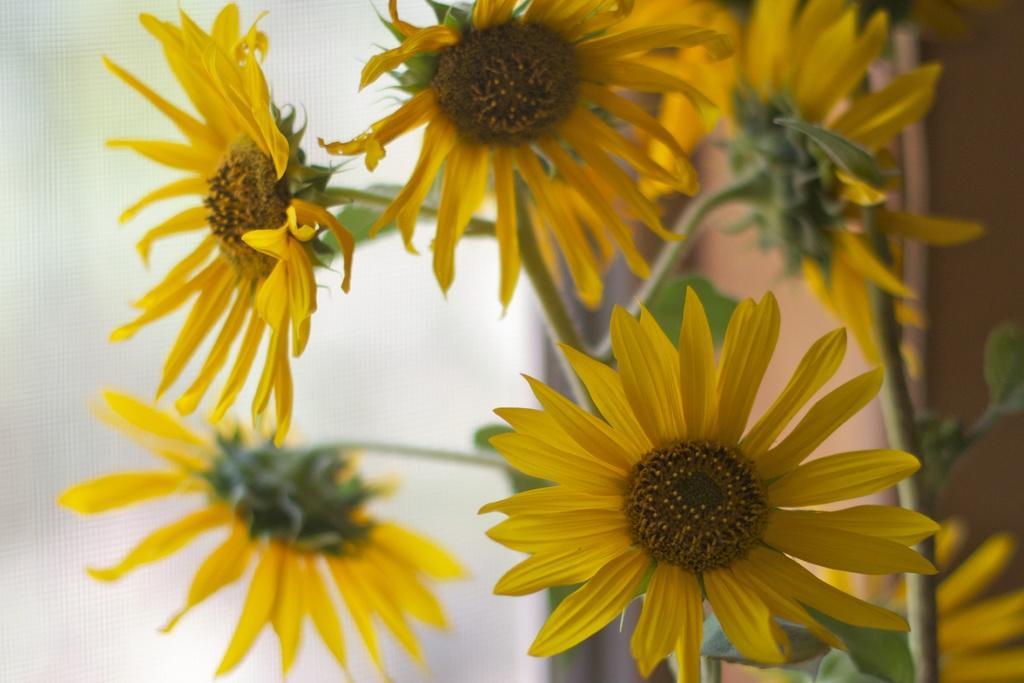Describe this image in one or two sentences. In this image I can see sunflower plants. The background of the image is blurred. 